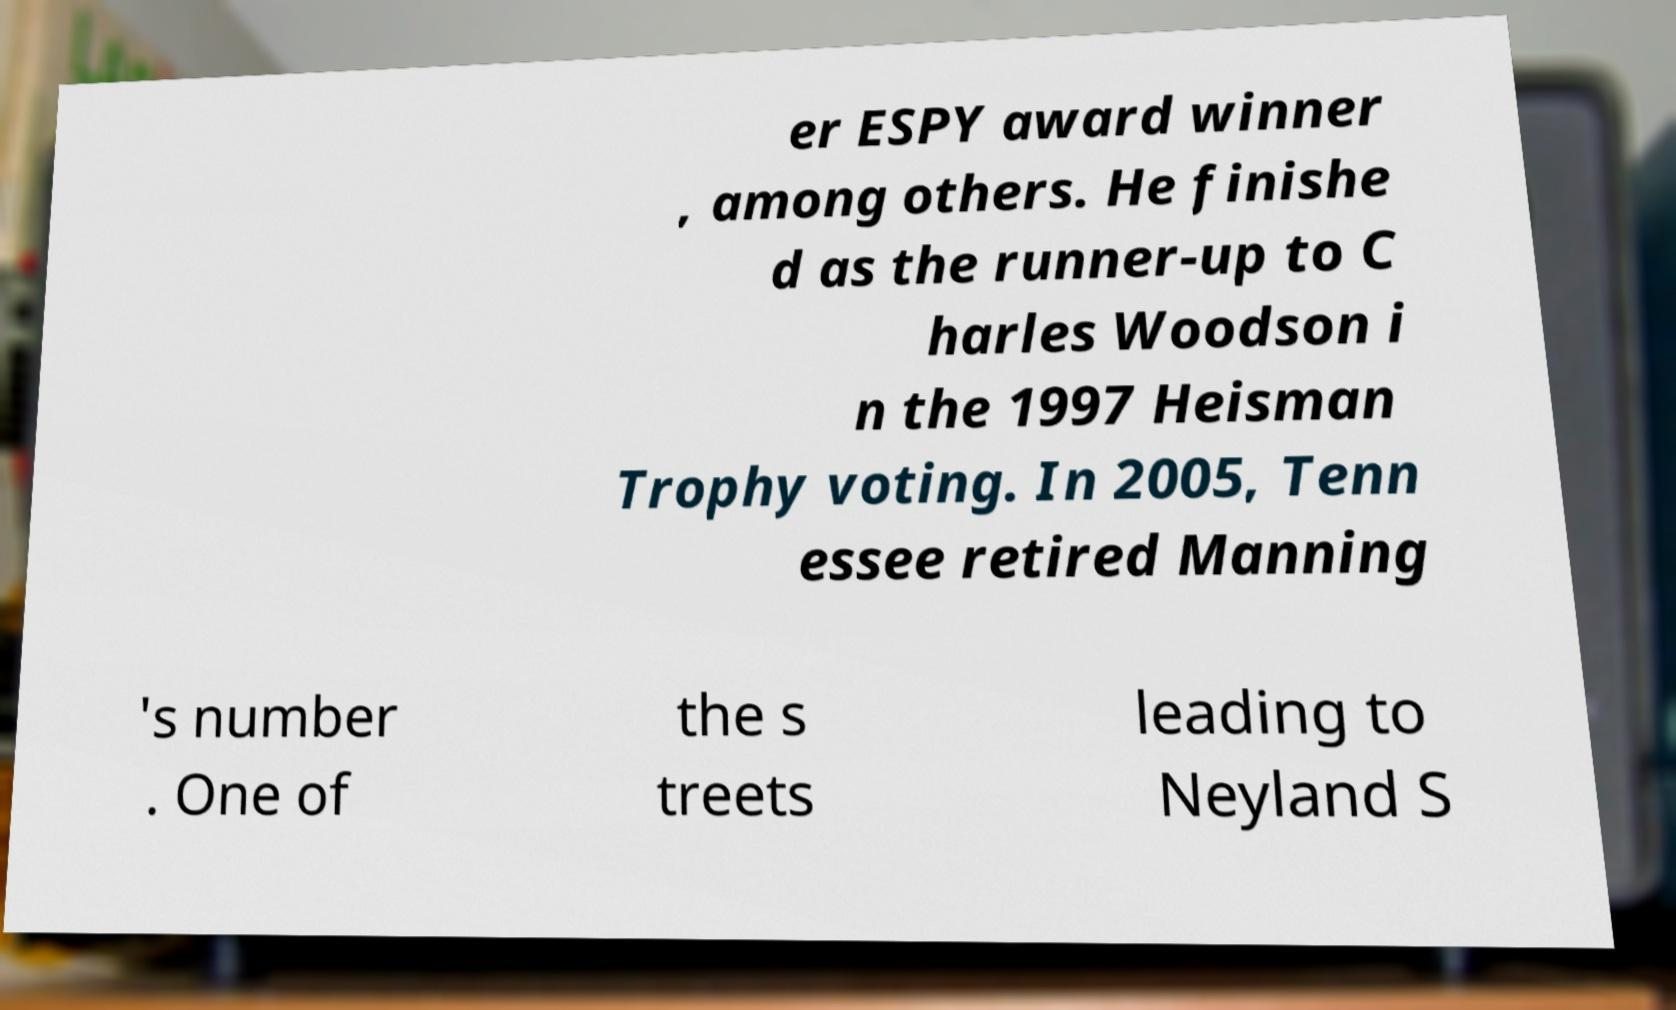Please identify and transcribe the text found in this image. er ESPY award winner , among others. He finishe d as the runner-up to C harles Woodson i n the 1997 Heisman Trophy voting. In 2005, Tenn essee retired Manning 's number . One of the s treets leading to Neyland S 